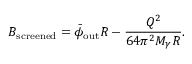Convert formula to latex. <formula><loc_0><loc_0><loc_500><loc_500>B _ { s c r e e n e d } = \bar { \phi } _ { o u t } R - \frac { Q ^ { 2 } } { 6 4 \pi ^ { 2 } M _ { \gamma } R } .</formula> 